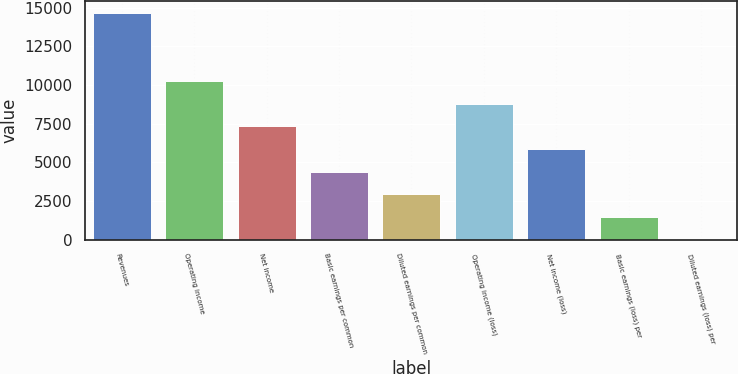<chart> <loc_0><loc_0><loc_500><loc_500><bar_chart><fcel>Revenues<fcel>Operating income<fcel>Net income<fcel>Basic earnings per common<fcel>Diluted earnings per common<fcel>Operating income (loss)<fcel>Net income (loss)<fcel>Basic earnings (loss) per<fcel>Diluted earnings (loss) per<nl><fcel>14663<fcel>10264.8<fcel>7332.72<fcel>4400.6<fcel>2934.54<fcel>8798.78<fcel>5866.66<fcel>1468.48<fcel>2.42<nl></chart> 